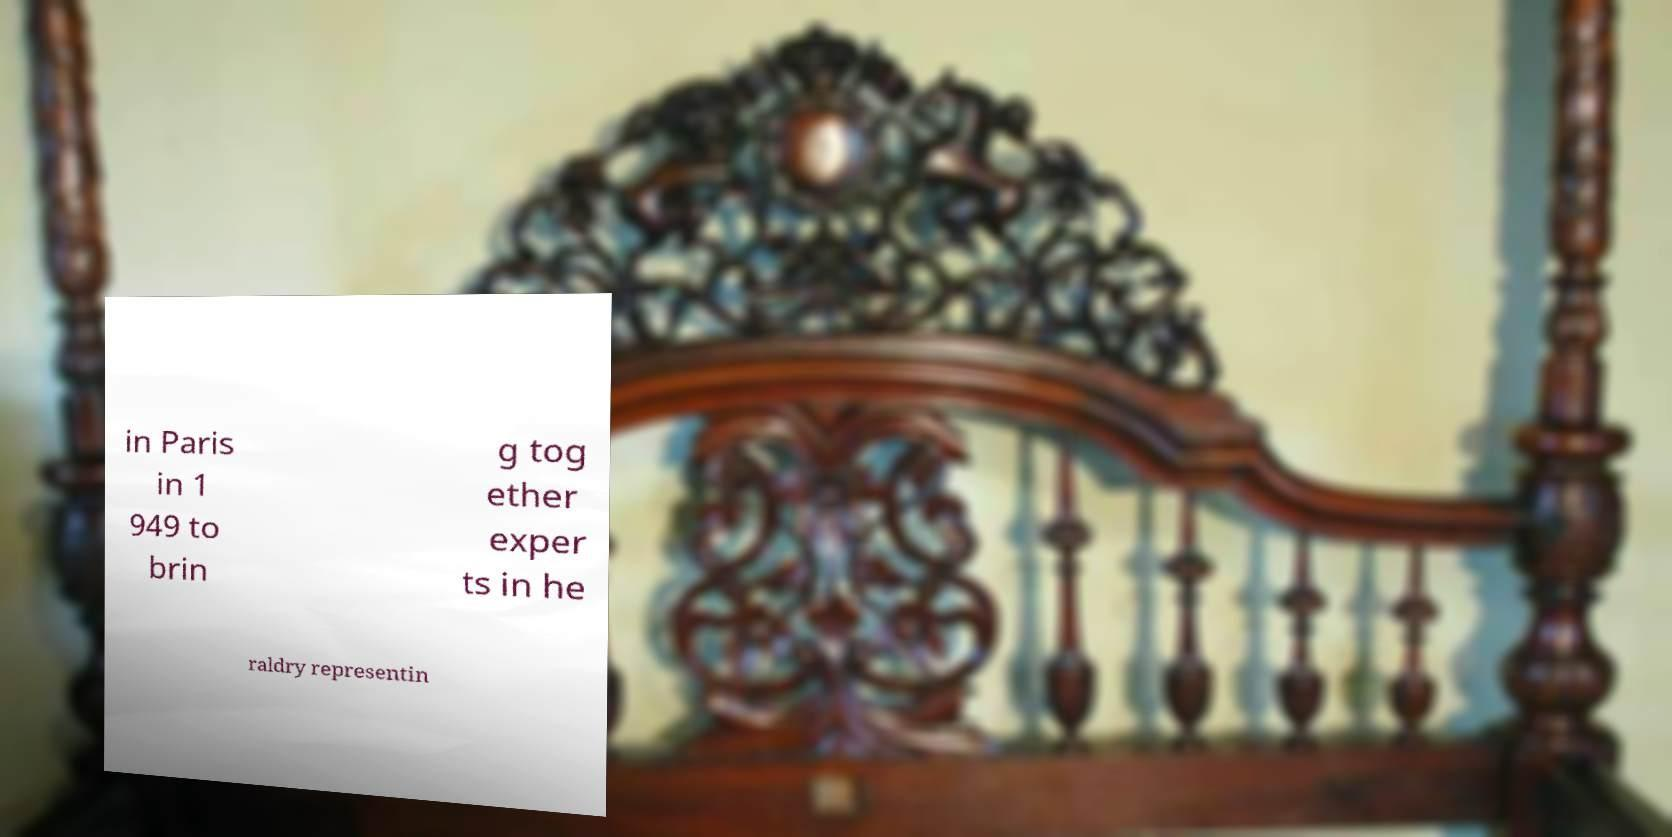What messages or text are displayed in this image? I need them in a readable, typed format. in Paris in 1 949 to brin g tog ether exper ts in he raldry representin 